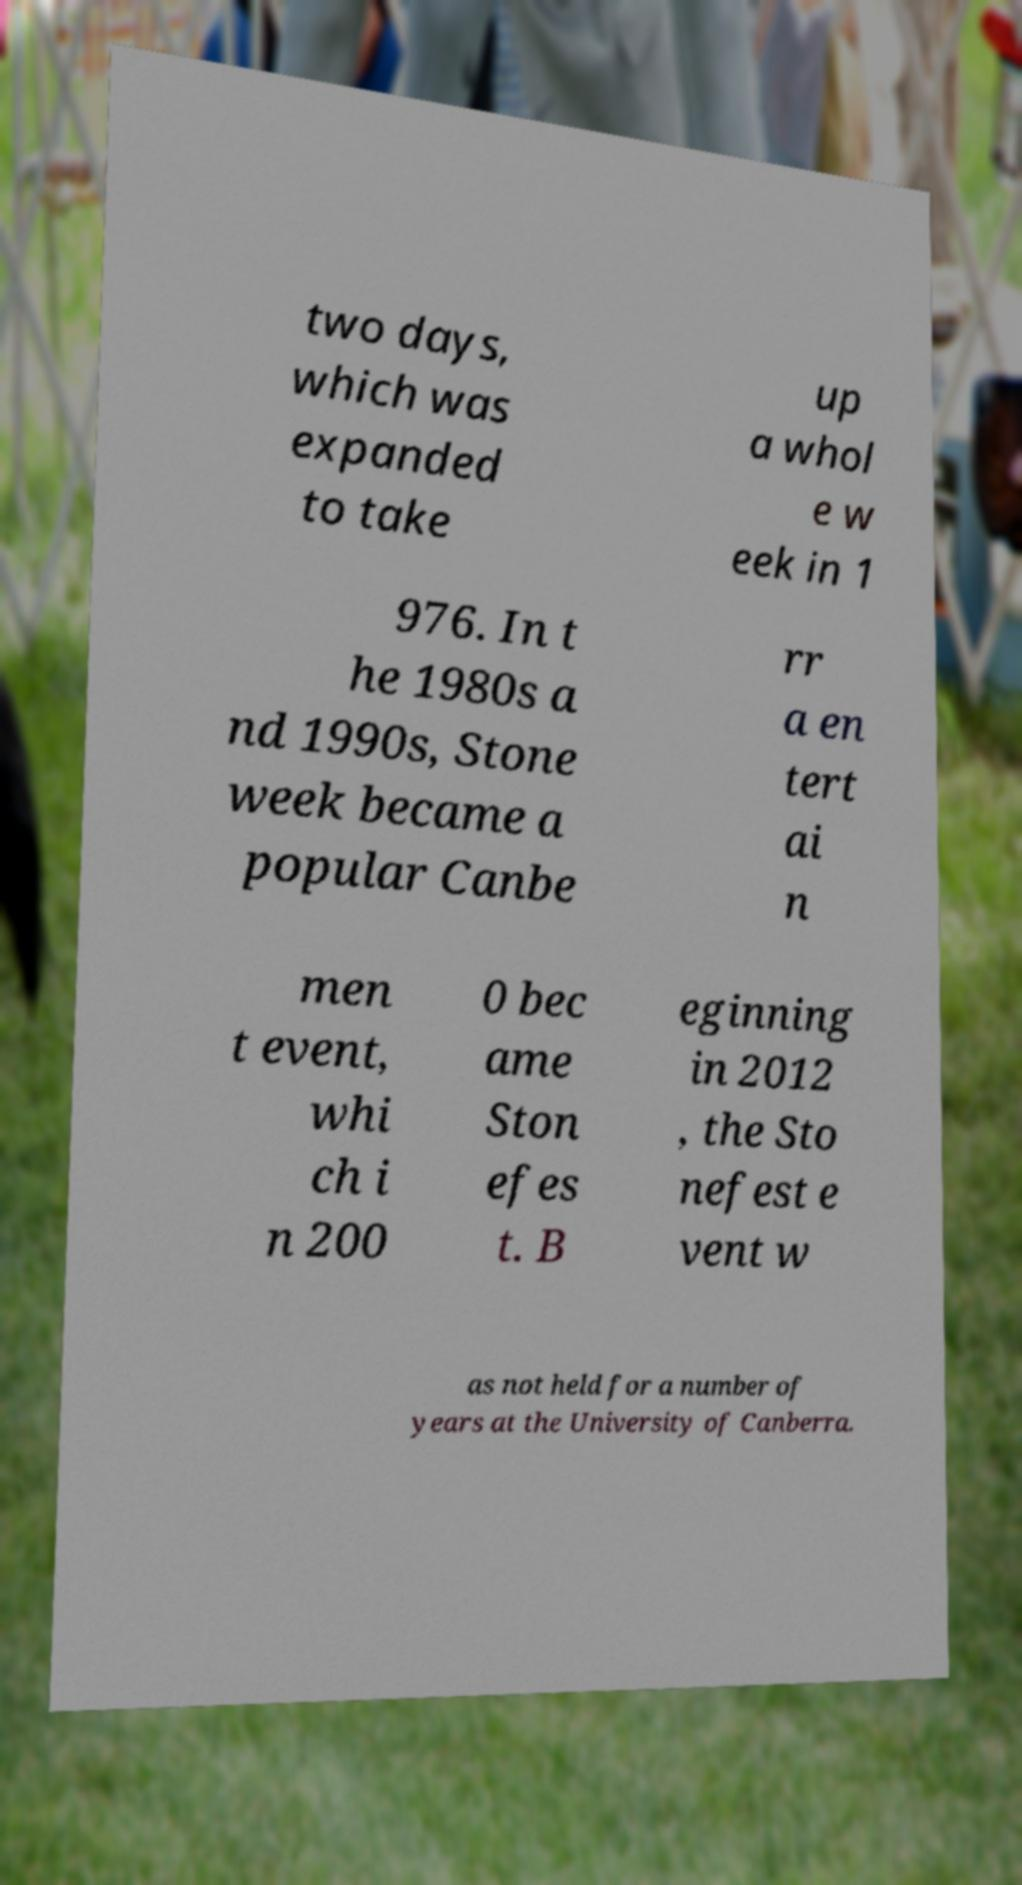Please identify and transcribe the text found in this image. two days, which was expanded to take up a whol e w eek in 1 976. In t he 1980s a nd 1990s, Stone week became a popular Canbe rr a en tert ai n men t event, whi ch i n 200 0 bec ame Ston efes t. B eginning in 2012 , the Sto nefest e vent w as not held for a number of years at the University of Canberra. 